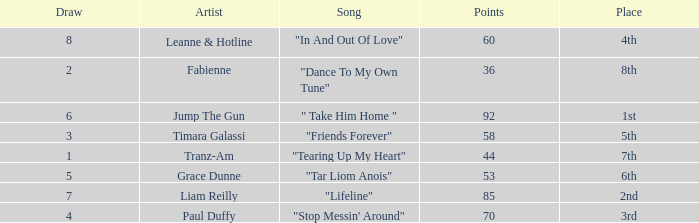Parse the table in full. {'header': ['Draw', 'Artist', 'Song', 'Points', 'Place'], 'rows': [['8', 'Leanne & Hotline', '"In And Out Of Love"', '60', '4th'], ['2', 'Fabienne', '"Dance To My Own Tune"', '36', '8th'], ['6', 'Jump The Gun', '" Take Him Home "', '92', '1st'], ['3', 'Timara Galassi', '"Friends Forever"', '58', '5th'], ['1', 'Tranz-Am', '"Tearing Up My Heart"', '44', '7th'], ['5', 'Grace Dunne', '"Tar Liom Anois"', '53', '6th'], ['7', 'Liam Reilly', '"Lifeline"', '85', '2nd'], ['4', 'Paul Duffy', '"Stop Messin\' Around"', '70', '3rd']]} What's the total number of points for grace dunne with a draw over 5? 0.0. 